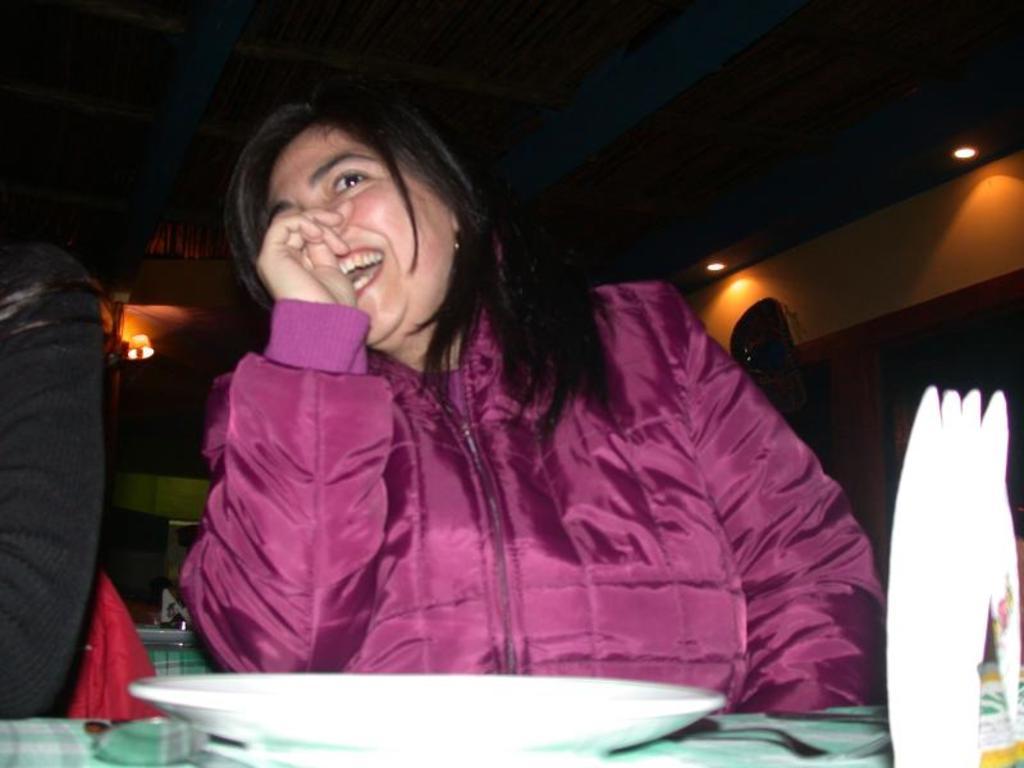Describe this image in one or two sentences. In this image I can see a woman wearing a red color jacket and she is smiling, sitting in front of the table , on the table I can see a white color plate. 